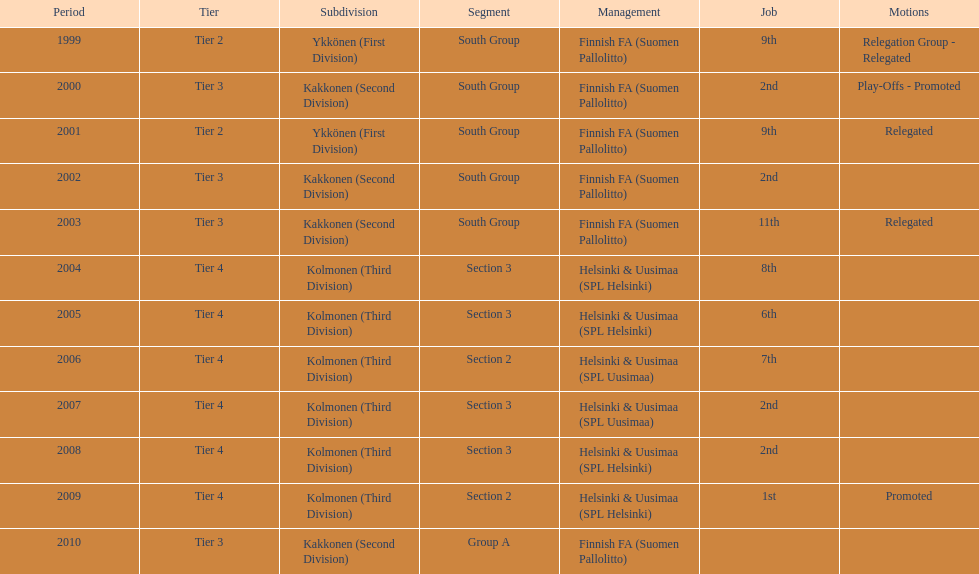How many tiers had more than one relegated movement? 1. 